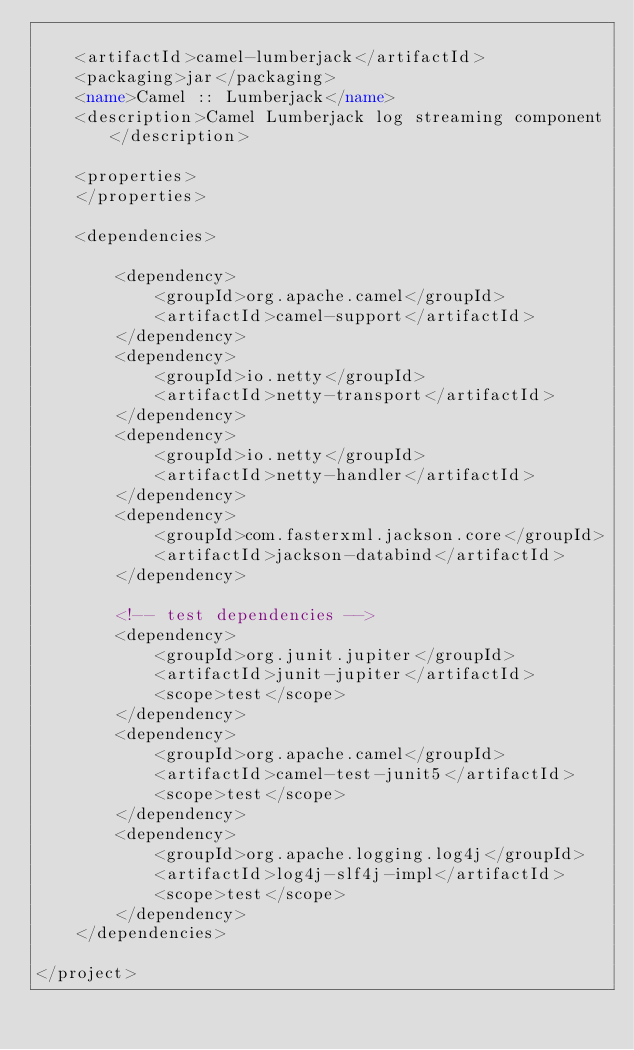<code> <loc_0><loc_0><loc_500><loc_500><_XML_>
    <artifactId>camel-lumberjack</artifactId>
    <packaging>jar</packaging>
    <name>Camel :: Lumberjack</name>
    <description>Camel Lumberjack log streaming component</description>

    <properties>
    </properties>

    <dependencies>

        <dependency>
            <groupId>org.apache.camel</groupId>
            <artifactId>camel-support</artifactId>
        </dependency>
        <dependency>
            <groupId>io.netty</groupId>
            <artifactId>netty-transport</artifactId>
        </dependency>
        <dependency>
            <groupId>io.netty</groupId>
            <artifactId>netty-handler</artifactId>
        </dependency>
        <dependency>
            <groupId>com.fasterxml.jackson.core</groupId>
            <artifactId>jackson-databind</artifactId>
        </dependency>

        <!-- test dependencies -->
        <dependency>
            <groupId>org.junit.jupiter</groupId>
            <artifactId>junit-jupiter</artifactId>
            <scope>test</scope>
        </dependency>
        <dependency>
            <groupId>org.apache.camel</groupId>
            <artifactId>camel-test-junit5</artifactId>
            <scope>test</scope>
        </dependency>
        <dependency>
            <groupId>org.apache.logging.log4j</groupId>
            <artifactId>log4j-slf4j-impl</artifactId>
            <scope>test</scope>
        </dependency>
    </dependencies>

</project>
</code> 